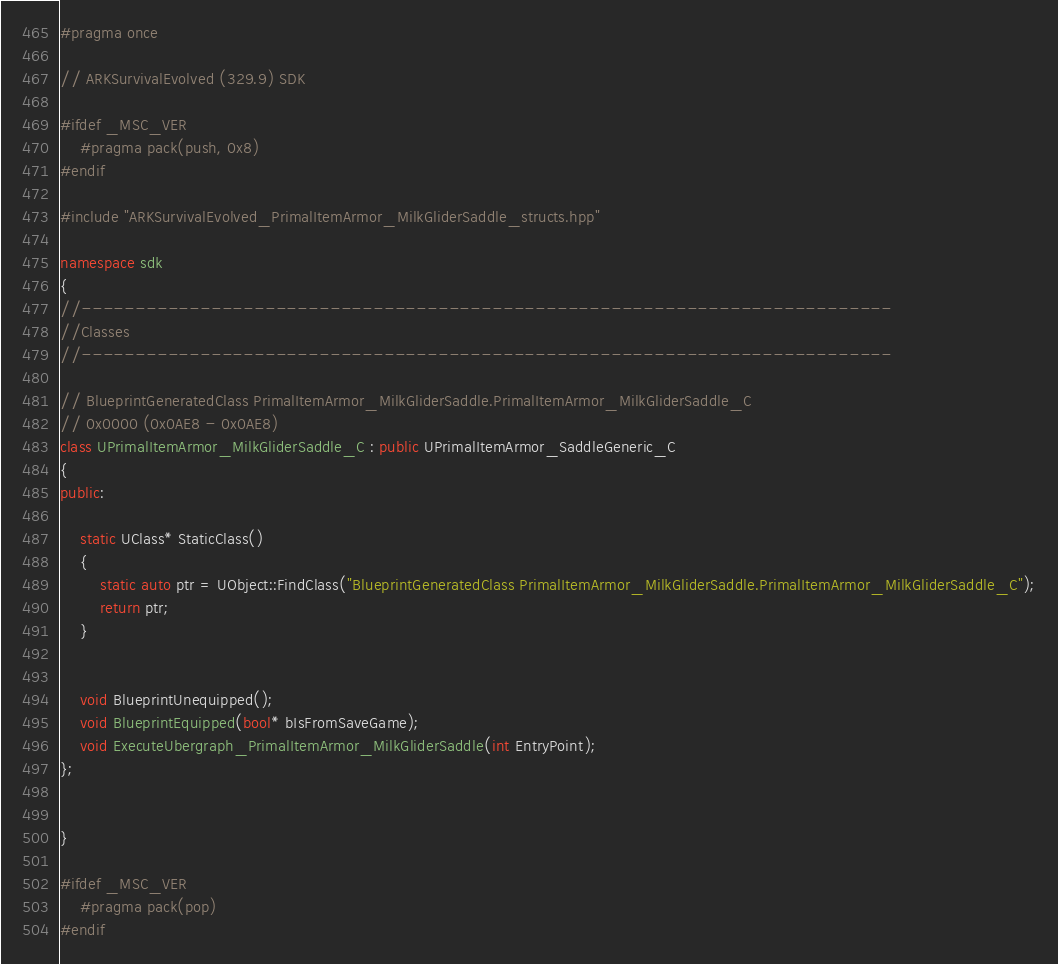<code> <loc_0><loc_0><loc_500><loc_500><_C++_>#pragma once

// ARKSurvivalEvolved (329.9) SDK

#ifdef _MSC_VER
	#pragma pack(push, 0x8)
#endif

#include "ARKSurvivalEvolved_PrimalItemArmor_MilkGliderSaddle_structs.hpp"

namespace sdk
{
//---------------------------------------------------------------------------
//Classes
//---------------------------------------------------------------------------

// BlueprintGeneratedClass PrimalItemArmor_MilkGliderSaddle.PrimalItemArmor_MilkGliderSaddle_C
// 0x0000 (0x0AE8 - 0x0AE8)
class UPrimalItemArmor_MilkGliderSaddle_C : public UPrimalItemArmor_SaddleGeneric_C
{
public:

	static UClass* StaticClass()
	{
		static auto ptr = UObject::FindClass("BlueprintGeneratedClass PrimalItemArmor_MilkGliderSaddle.PrimalItemArmor_MilkGliderSaddle_C");
		return ptr;
	}


	void BlueprintUnequipped();
	void BlueprintEquipped(bool* bIsFromSaveGame);
	void ExecuteUbergraph_PrimalItemArmor_MilkGliderSaddle(int EntryPoint);
};


}

#ifdef _MSC_VER
	#pragma pack(pop)
#endif
</code> 